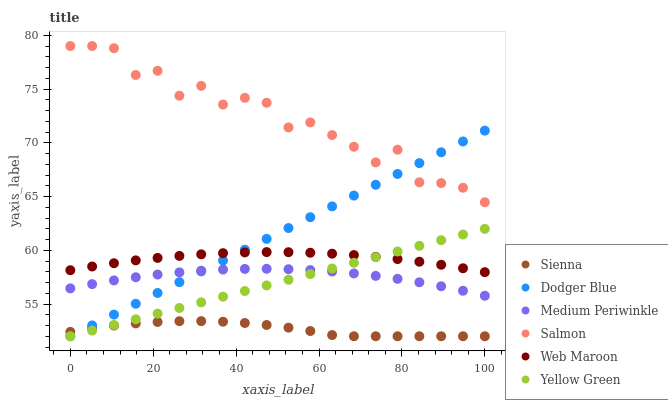Does Sienna have the minimum area under the curve?
Answer yes or no. Yes. Does Salmon have the maximum area under the curve?
Answer yes or no. Yes. Does Web Maroon have the minimum area under the curve?
Answer yes or no. No. Does Web Maroon have the maximum area under the curve?
Answer yes or no. No. Is Yellow Green the smoothest?
Answer yes or no. Yes. Is Salmon the roughest?
Answer yes or no. Yes. Is Web Maroon the smoothest?
Answer yes or no. No. Is Web Maroon the roughest?
Answer yes or no. No. Does Yellow Green have the lowest value?
Answer yes or no. Yes. Does Web Maroon have the lowest value?
Answer yes or no. No. Does Salmon have the highest value?
Answer yes or no. Yes. Does Web Maroon have the highest value?
Answer yes or no. No. Is Medium Periwinkle less than Web Maroon?
Answer yes or no. Yes. Is Salmon greater than Web Maroon?
Answer yes or no. Yes. Does Medium Periwinkle intersect Dodger Blue?
Answer yes or no. Yes. Is Medium Periwinkle less than Dodger Blue?
Answer yes or no. No. Is Medium Periwinkle greater than Dodger Blue?
Answer yes or no. No. Does Medium Periwinkle intersect Web Maroon?
Answer yes or no. No. 